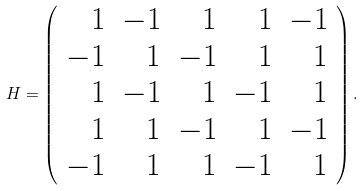<formula> <loc_0><loc_0><loc_500><loc_500>H = \left ( \begin{array} { r r r r r } 1 & - 1 & 1 & 1 & - 1 \\ - 1 & 1 & - 1 & 1 & 1 \\ 1 & - 1 & 1 & - 1 & 1 \\ 1 & 1 & - 1 & 1 & - 1 \\ - 1 & 1 & 1 & - 1 & 1 \end{array} \right ) .</formula> 